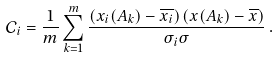Convert formula to latex. <formula><loc_0><loc_0><loc_500><loc_500>\mathcal { C } _ { i } = \frac { 1 } { m } \sum _ { k = 1 } ^ { m } \frac { \left ( x _ { i } ( A _ { k } ) - \overline { x _ { i } } \right ) \left ( x ( A _ { k } ) - \overline { x } \right ) } { \sigma _ { i } \sigma } \, .</formula> 